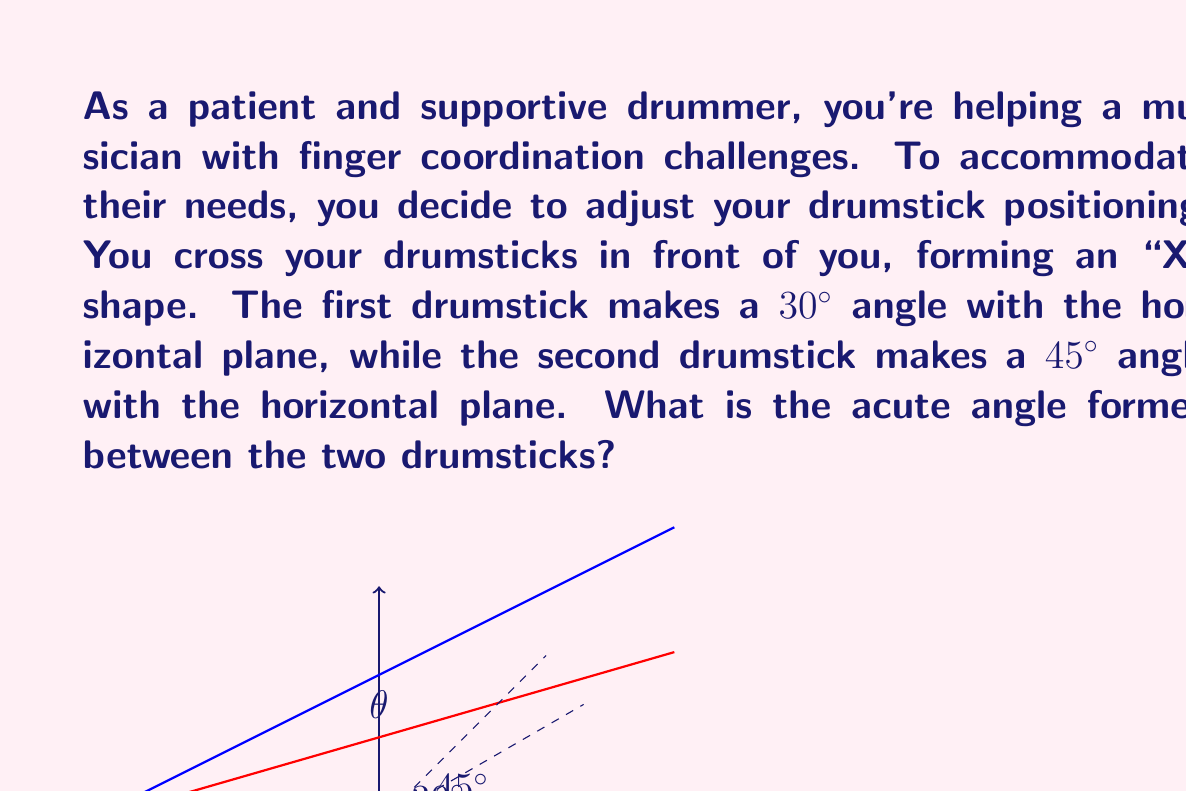What is the answer to this math problem? To find the angle between the two drumsticks, we can use the formula for the angle between two lines in 3D space. Let's approach this step-by-step:

1) First, we need to represent each drumstick as a vector. We can do this using direction vectors:
   - For the first drumstick: $\vec{v_1} = (\cos 30°, \sin 30°, 0) = (\frac{\sqrt{3}}{2}, \frac{1}{2}, 0)$
   - For the second drumstick: $\vec{v_2} = (\cos 45°, \sin 45°, 0) = (\frac{\sqrt{2}}{2}, \frac{\sqrt{2}}{2}, 0)$

2) The formula for the angle $\theta$ between two vectors $\vec{v_1}$ and $\vec{v_2}$ is:

   $$\cos \theta = \frac{\vec{v_1} \cdot \vec{v_2}}{|\vec{v_1}||\vec{v_2}|}$$

3) Let's calculate the dot product $\vec{v_1} \cdot \vec{v_2}$:
   $$\vec{v_1} \cdot \vec{v_2} = \frac{\sqrt{3}}{2} \cdot \frac{\sqrt{2}}{2} + \frac{1}{2} \cdot \frac{\sqrt{2}}{2} + 0 \cdot 0 = \frac{\sqrt{6}}{4} + \frac{\sqrt{2}}{4} = \frac{\sqrt{6} + \sqrt{2}}{4}$$

4) Now, let's calculate the magnitudes:
   $|\vec{v_1}| = \sqrt{(\frac{\sqrt{3}}{2})^2 + (\frac{1}{2})^2 + 0^2} = 1$
   $|\vec{v_2}| = \sqrt{(\frac{\sqrt{2}}{2})^2 + (\frac{\sqrt{2}}{2})^2 + 0^2} = 1$

5) Substituting into our formula:

   $$\cos \theta = \frac{\frac{\sqrt{6} + \sqrt{2}}{4}}{1 \cdot 1} = \frac{\sqrt{6} + \sqrt{2}}{4}$$

6) To find $\theta$, we take the inverse cosine (arccos) of both sides:

   $$\theta = \arccos(\frac{\sqrt{6} + \sqrt{2}}{4})$$

7) Using a calculator or computer, we can evaluate this to get the angle in degrees.
Answer: $\theta \approx 15.0°$ (rounded to one decimal place) 